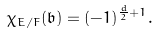<formula> <loc_0><loc_0><loc_500><loc_500>\chi _ { E / F } ( \mathfrak { b } ) = ( - 1 ) ^ { \frac { d } { 2 } + 1 } .</formula> 